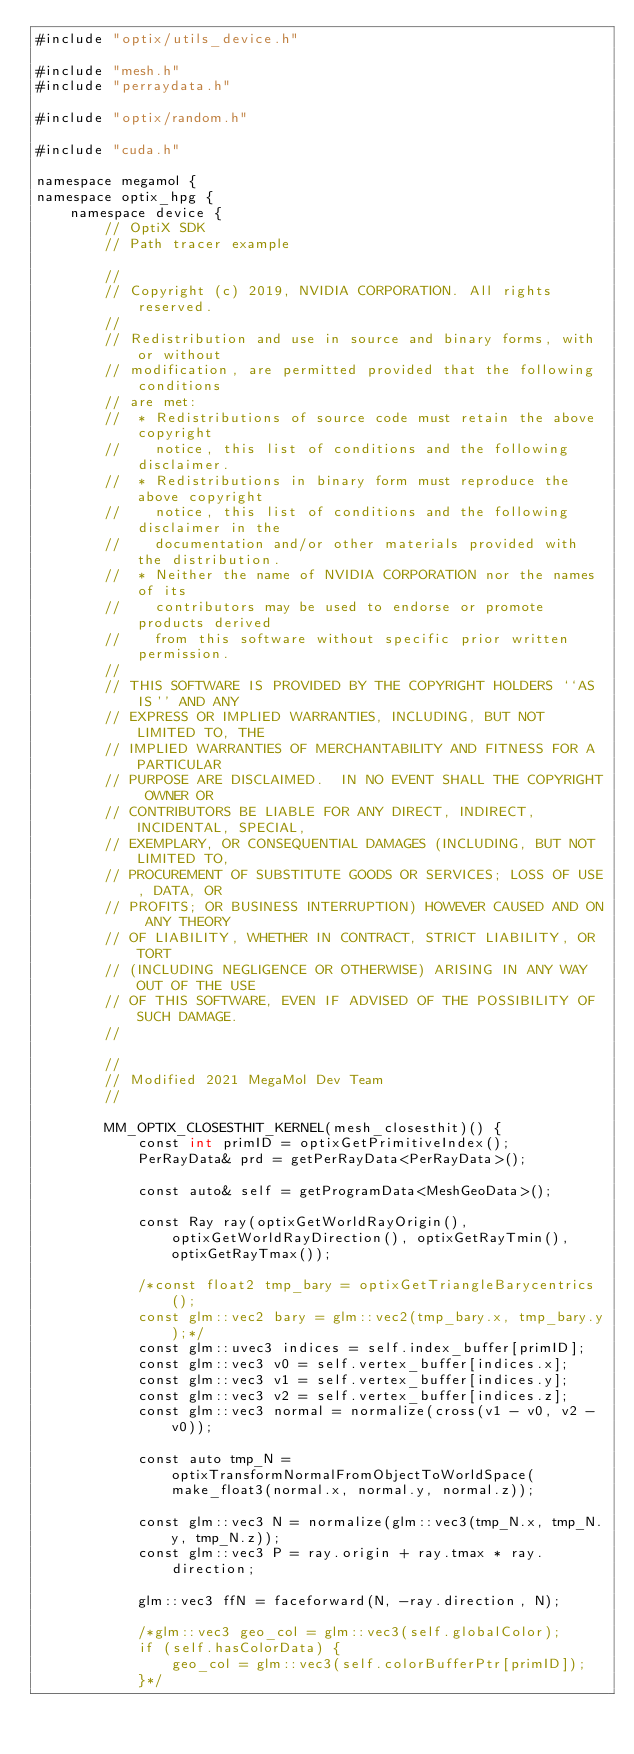<code> <loc_0><loc_0><loc_500><loc_500><_Cuda_>#include "optix/utils_device.h"

#include "mesh.h"
#include "perraydata.h"

#include "optix/random.h"

#include "cuda.h"

namespace megamol {
namespace optix_hpg {
    namespace device {
        // OptiX SDK
        // Path tracer example

        //
        // Copyright (c) 2019, NVIDIA CORPORATION. All rights reserved.
        //
        // Redistribution and use in source and binary forms, with or without
        // modification, are permitted provided that the following conditions
        // are met:
        //  * Redistributions of source code must retain the above copyright
        //    notice, this list of conditions and the following disclaimer.
        //  * Redistributions in binary form must reproduce the above copyright
        //    notice, this list of conditions and the following disclaimer in the
        //    documentation and/or other materials provided with the distribution.
        //  * Neither the name of NVIDIA CORPORATION nor the names of its
        //    contributors may be used to endorse or promote products derived
        //    from this software without specific prior written permission.
        //
        // THIS SOFTWARE IS PROVIDED BY THE COPYRIGHT HOLDERS ``AS IS'' AND ANY
        // EXPRESS OR IMPLIED WARRANTIES, INCLUDING, BUT NOT LIMITED TO, THE
        // IMPLIED WARRANTIES OF MERCHANTABILITY AND FITNESS FOR A PARTICULAR
        // PURPOSE ARE DISCLAIMED.  IN NO EVENT SHALL THE COPYRIGHT OWNER OR
        // CONTRIBUTORS BE LIABLE FOR ANY DIRECT, INDIRECT, INCIDENTAL, SPECIAL,
        // EXEMPLARY, OR CONSEQUENTIAL DAMAGES (INCLUDING, BUT NOT LIMITED TO,
        // PROCUREMENT OF SUBSTITUTE GOODS OR SERVICES; LOSS OF USE, DATA, OR
        // PROFITS; OR BUSINESS INTERRUPTION) HOWEVER CAUSED AND ON ANY THEORY
        // OF LIABILITY, WHETHER IN CONTRACT, STRICT LIABILITY, OR TORT
        // (INCLUDING NEGLIGENCE OR OTHERWISE) ARISING IN ANY WAY OUT OF THE USE
        // OF THIS SOFTWARE, EVEN IF ADVISED OF THE POSSIBILITY OF SUCH DAMAGE.
        //

        //
        // Modified 2021 MegaMol Dev Team
        //

        MM_OPTIX_CLOSESTHIT_KERNEL(mesh_closesthit)() {
            const int primID = optixGetPrimitiveIndex();
            PerRayData& prd = getPerRayData<PerRayData>();

            const auto& self = getProgramData<MeshGeoData>();

            const Ray ray(optixGetWorldRayOrigin(), optixGetWorldRayDirection(), optixGetRayTmin(), optixGetRayTmax());

            /*const float2 tmp_bary = optixGetTriangleBarycentrics();
            const glm::vec2 bary = glm::vec2(tmp_bary.x, tmp_bary.y);*/
            const glm::uvec3 indices = self.index_buffer[primID];
            const glm::vec3 v0 = self.vertex_buffer[indices.x];
            const glm::vec3 v1 = self.vertex_buffer[indices.y];
            const glm::vec3 v2 = self.vertex_buffer[indices.z];
            const glm::vec3 normal = normalize(cross(v1 - v0, v2 - v0));

            const auto tmp_N = optixTransformNormalFromObjectToWorldSpace(make_float3(normal.x, normal.y, normal.z));

            const glm::vec3 N = normalize(glm::vec3(tmp_N.x, tmp_N.y, tmp_N.z));
            const glm::vec3 P = ray.origin + ray.tmax * ray.direction;

            glm::vec3 ffN = faceforward(N, -ray.direction, N);

            /*glm::vec3 geo_col = glm::vec3(self.globalColor);
            if (self.hasColorData) {
                geo_col = glm::vec3(self.colorBufferPtr[primID]);
            }*/
</code> 